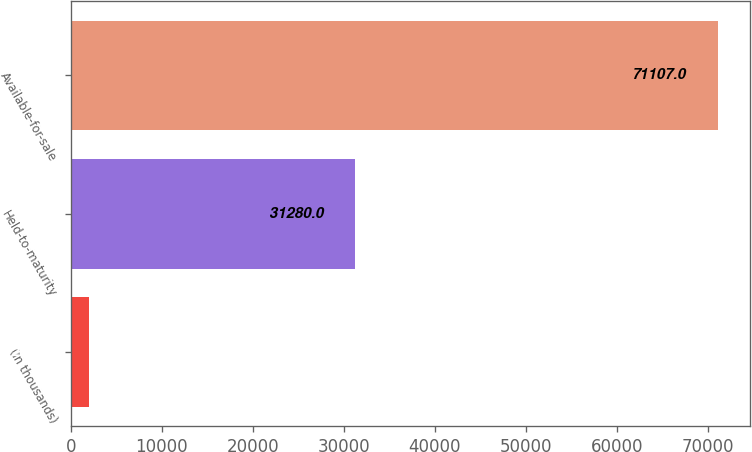Convert chart. <chart><loc_0><loc_0><loc_500><loc_500><bar_chart><fcel>(In thousands)<fcel>Held-to-maturity<fcel>Available-for-sale<nl><fcel>2013<fcel>31280<fcel>71107<nl></chart> 